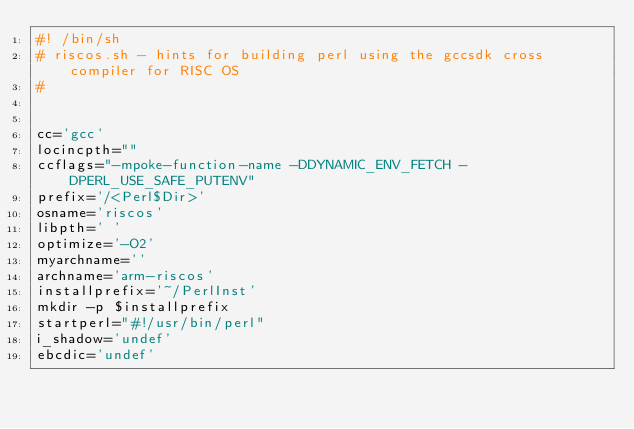<code> <loc_0><loc_0><loc_500><loc_500><_Bash_>#! /bin/sh
# riscos.sh - hints for building perl using the gccsdk cross compiler for RISC OS
#


cc='gcc'
locincpth=""
ccflags="-mpoke-function-name -DDYNAMIC_ENV_FETCH -DPERL_USE_SAFE_PUTENV"
prefix='/<Perl$Dir>'
osname='riscos'
libpth=' '
optimize='-O2'
myarchname=''
archname='arm-riscos'
installprefix='~/PerlInst'
mkdir -p $installprefix
startperl="#!/usr/bin/perl"
i_shadow='undef'
ebcdic='undef'

</code> 